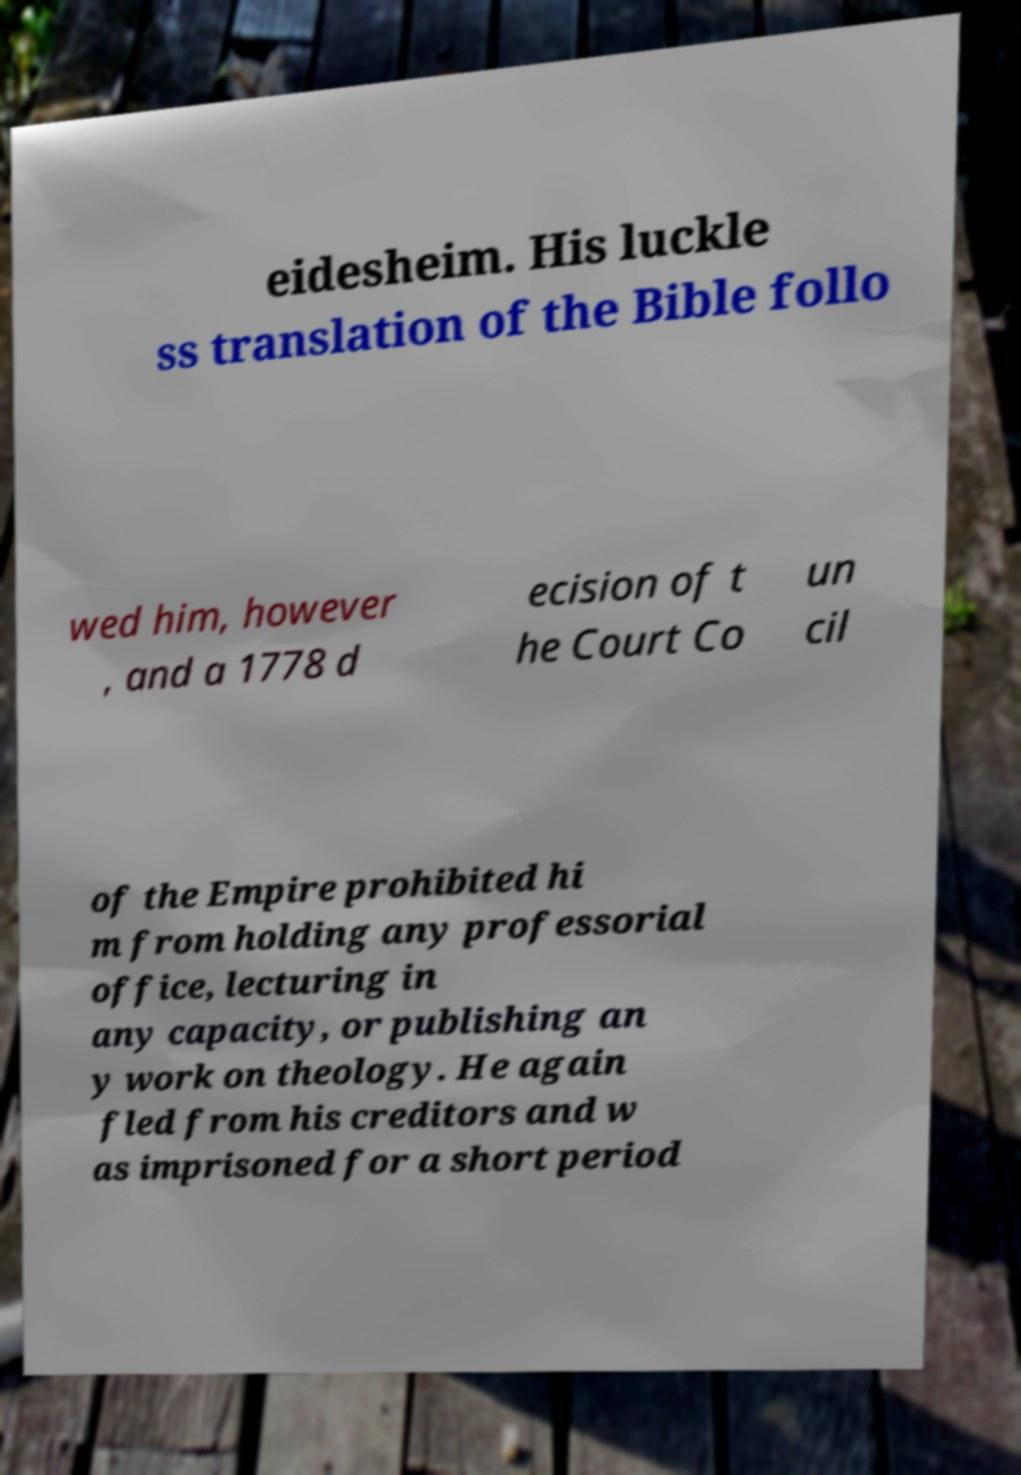Can you accurately transcribe the text from the provided image for me? eidesheim. His luckle ss translation of the Bible follo wed him, however , and a 1778 d ecision of t he Court Co un cil of the Empire prohibited hi m from holding any professorial office, lecturing in any capacity, or publishing an y work on theology. He again fled from his creditors and w as imprisoned for a short period 